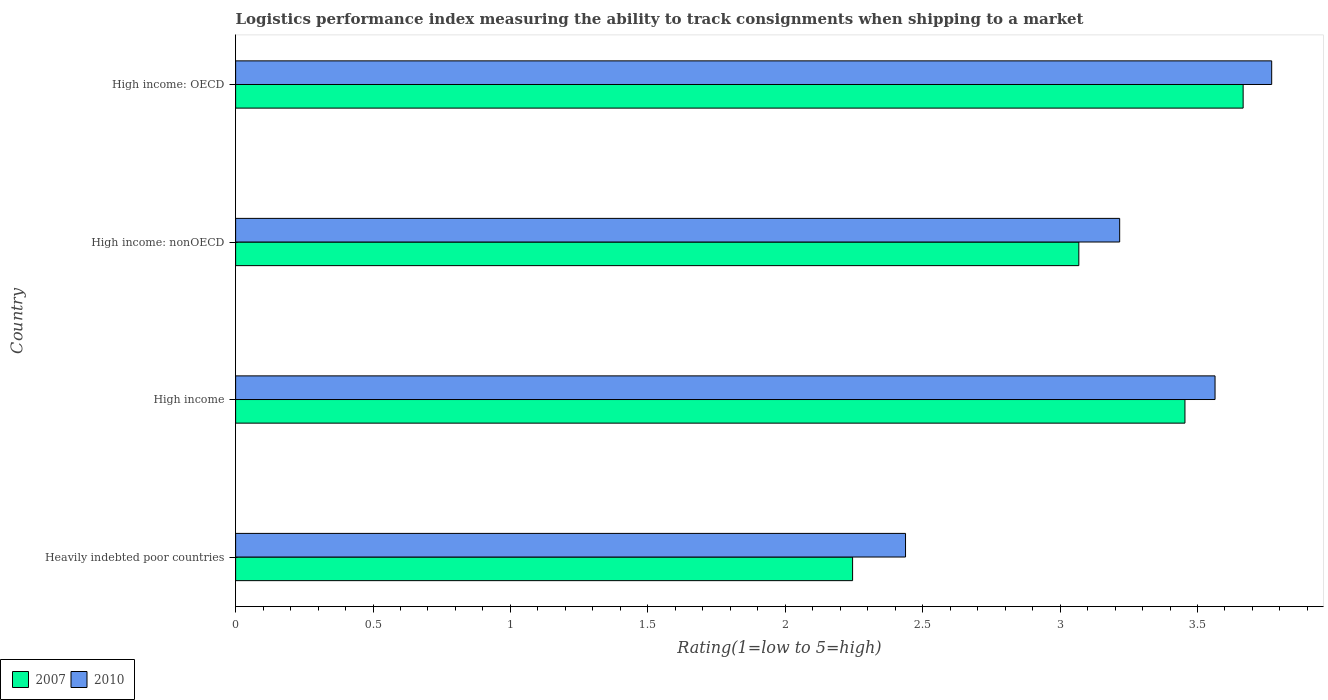Are the number of bars on each tick of the Y-axis equal?
Your response must be concise. Yes. How many bars are there on the 2nd tick from the bottom?
Make the answer very short. 2. What is the label of the 1st group of bars from the top?
Provide a short and direct response. High income: OECD. In how many cases, is the number of bars for a given country not equal to the number of legend labels?
Offer a very short reply. 0. What is the Logistic performance index in 2010 in High income: nonOECD?
Ensure brevity in your answer.  3.22. Across all countries, what is the maximum Logistic performance index in 2010?
Ensure brevity in your answer.  3.77. Across all countries, what is the minimum Logistic performance index in 2007?
Give a very brief answer. 2.25. In which country was the Logistic performance index in 2010 maximum?
Your response must be concise. High income: OECD. In which country was the Logistic performance index in 2010 minimum?
Offer a terse response. Heavily indebted poor countries. What is the total Logistic performance index in 2010 in the graph?
Ensure brevity in your answer.  12.99. What is the difference between the Logistic performance index in 2010 in Heavily indebted poor countries and that in High income: OECD?
Offer a terse response. -1.33. What is the difference between the Logistic performance index in 2007 in High income: nonOECD and the Logistic performance index in 2010 in High income?
Make the answer very short. -0.5. What is the average Logistic performance index in 2010 per country?
Provide a short and direct response. 3.25. What is the difference between the Logistic performance index in 2007 and Logistic performance index in 2010 in High income: nonOECD?
Your response must be concise. -0.15. What is the ratio of the Logistic performance index in 2007 in High income to that in High income: nonOECD?
Give a very brief answer. 1.13. Is the difference between the Logistic performance index in 2007 in High income and High income: nonOECD greater than the difference between the Logistic performance index in 2010 in High income and High income: nonOECD?
Ensure brevity in your answer.  Yes. What is the difference between the highest and the second highest Logistic performance index in 2007?
Your answer should be very brief. 0.21. What is the difference between the highest and the lowest Logistic performance index in 2010?
Your response must be concise. 1.33. Is the sum of the Logistic performance index in 2010 in High income and High income: OECD greater than the maximum Logistic performance index in 2007 across all countries?
Your response must be concise. Yes. What does the 1st bar from the bottom in High income: nonOECD represents?
Offer a very short reply. 2007. Are all the bars in the graph horizontal?
Ensure brevity in your answer.  Yes. What is the difference between two consecutive major ticks on the X-axis?
Your answer should be compact. 0.5. What is the title of the graph?
Ensure brevity in your answer.  Logistics performance index measuring the ability to track consignments when shipping to a market. What is the label or title of the X-axis?
Offer a terse response. Rating(1=low to 5=high). What is the label or title of the Y-axis?
Make the answer very short. Country. What is the Rating(1=low to 5=high) in 2007 in Heavily indebted poor countries?
Give a very brief answer. 2.25. What is the Rating(1=low to 5=high) of 2010 in Heavily indebted poor countries?
Your response must be concise. 2.44. What is the Rating(1=low to 5=high) of 2007 in High income?
Your answer should be compact. 3.45. What is the Rating(1=low to 5=high) in 2010 in High income?
Offer a terse response. 3.56. What is the Rating(1=low to 5=high) in 2007 in High income: nonOECD?
Your answer should be compact. 3.07. What is the Rating(1=low to 5=high) in 2010 in High income: nonOECD?
Provide a short and direct response. 3.22. What is the Rating(1=low to 5=high) of 2007 in High income: OECD?
Keep it short and to the point. 3.67. What is the Rating(1=low to 5=high) in 2010 in High income: OECD?
Make the answer very short. 3.77. Across all countries, what is the maximum Rating(1=low to 5=high) in 2007?
Your answer should be very brief. 3.67. Across all countries, what is the maximum Rating(1=low to 5=high) of 2010?
Provide a succinct answer. 3.77. Across all countries, what is the minimum Rating(1=low to 5=high) in 2007?
Ensure brevity in your answer.  2.25. Across all countries, what is the minimum Rating(1=low to 5=high) in 2010?
Offer a very short reply. 2.44. What is the total Rating(1=low to 5=high) of 2007 in the graph?
Provide a short and direct response. 12.43. What is the total Rating(1=low to 5=high) of 2010 in the graph?
Your response must be concise. 12.99. What is the difference between the Rating(1=low to 5=high) of 2007 in Heavily indebted poor countries and that in High income?
Provide a short and direct response. -1.21. What is the difference between the Rating(1=low to 5=high) of 2010 in Heavily indebted poor countries and that in High income?
Provide a short and direct response. -1.13. What is the difference between the Rating(1=low to 5=high) in 2007 in Heavily indebted poor countries and that in High income: nonOECD?
Provide a short and direct response. -0.82. What is the difference between the Rating(1=low to 5=high) of 2010 in Heavily indebted poor countries and that in High income: nonOECD?
Your response must be concise. -0.78. What is the difference between the Rating(1=low to 5=high) in 2007 in Heavily indebted poor countries and that in High income: OECD?
Your answer should be compact. -1.42. What is the difference between the Rating(1=low to 5=high) of 2010 in Heavily indebted poor countries and that in High income: OECD?
Give a very brief answer. -1.33. What is the difference between the Rating(1=low to 5=high) of 2007 in High income and that in High income: nonOECD?
Ensure brevity in your answer.  0.39. What is the difference between the Rating(1=low to 5=high) in 2010 in High income and that in High income: nonOECD?
Make the answer very short. 0.35. What is the difference between the Rating(1=low to 5=high) of 2007 in High income and that in High income: OECD?
Offer a terse response. -0.21. What is the difference between the Rating(1=low to 5=high) of 2010 in High income and that in High income: OECD?
Provide a succinct answer. -0.21. What is the difference between the Rating(1=low to 5=high) of 2007 in High income: nonOECD and that in High income: OECD?
Make the answer very short. -0.6. What is the difference between the Rating(1=low to 5=high) of 2010 in High income: nonOECD and that in High income: OECD?
Provide a short and direct response. -0.55. What is the difference between the Rating(1=low to 5=high) in 2007 in Heavily indebted poor countries and the Rating(1=low to 5=high) in 2010 in High income?
Make the answer very short. -1.32. What is the difference between the Rating(1=low to 5=high) of 2007 in Heavily indebted poor countries and the Rating(1=low to 5=high) of 2010 in High income: nonOECD?
Offer a very short reply. -0.97. What is the difference between the Rating(1=low to 5=high) of 2007 in Heavily indebted poor countries and the Rating(1=low to 5=high) of 2010 in High income: OECD?
Ensure brevity in your answer.  -1.52. What is the difference between the Rating(1=low to 5=high) in 2007 in High income and the Rating(1=low to 5=high) in 2010 in High income: nonOECD?
Keep it short and to the point. 0.24. What is the difference between the Rating(1=low to 5=high) in 2007 in High income and the Rating(1=low to 5=high) in 2010 in High income: OECD?
Keep it short and to the point. -0.32. What is the difference between the Rating(1=low to 5=high) in 2007 in High income: nonOECD and the Rating(1=low to 5=high) in 2010 in High income: OECD?
Provide a succinct answer. -0.7. What is the average Rating(1=low to 5=high) in 2007 per country?
Offer a very short reply. 3.11. What is the average Rating(1=low to 5=high) of 2010 per country?
Provide a short and direct response. 3.25. What is the difference between the Rating(1=low to 5=high) of 2007 and Rating(1=low to 5=high) of 2010 in Heavily indebted poor countries?
Make the answer very short. -0.19. What is the difference between the Rating(1=low to 5=high) in 2007 and Rating(1=low to 5=high) in 2010 in High income?
Provide a succinct answer. -0.11. What is the difference between the Rating(1=low to 5=high) of 2007 and Rating(1=low to 5=high) of 2010 in High income: nonOECD?
Provide a short and direct response. -0.15. What is the difference between the Rating(1=low to 5=high) in 2007 and Rating(1=low to 5=high) in 2010 in High income: OECD?
Give a very brief answer. -0.1. What is the ratio of the Rating(1=low to 5=high) in 2007 in Heavily indebted poor countries to that in High income?
Keep it short and to the point. 0.65. What is the ratio of the Rating(1=low to 5=high) of 2010 in Heavily indebted poor countries to that in High income?
Offer a very short reply. 0.68. What is the ratio of the Rating(1=low to 5=high) of 2007 in Heavily indebted poor countries to that in High income: nonOECD?
Your answer should be compact. 0.73. What is the ratio of the Rating(1=low to 5=high) in 2010 in Heavily indebted poor countries to that in High income: nonOECD?
Keep it short and to the point. 0.76. What is the ratio of the Rating(1=low to 5=high) of 2007 in Heavily indebted poor countries to that in High income: OECD?
Offer a terse response. 0.61. What is the ratio of the Rating(1=low to 5=high) of 2010 in Heavily indebted poor countries to that in High income: OECD?
Offer a terse response. 0.65. What is the ratio of the Rating(1=low to 5=high) of 2007 in High income to that in High income: nonOECD?
Provide a succinct answer. 1.13. What is the ratio of the Rating(1=low to 5=high) in 2010 in High income to that in High income: nonOECD?
Provide a short and direct response. 1.11. What is the ratio of the Rating(1=low to 5=high) of 2007 in High income to that in High income: OECD?
Provide a succinct answer. 0.94. What is the ratio of the Rating(1=low to 5=high) of 2010 in High income to that in High income: OECD?
Make the answer very short. 0.95. What is the ratio of the Rating(1=low to 5=high) of 2007 in High income: nonOECD to that in High income: OECD?
Give a very brief answer. 0.84. What is the ratio of the Rating(1=low to 5=high) in 2010 in High income: nonOECD to that in High income: OECD?
Make the answer very short. 0.85. What is the difference between the highest and the second highest Rating(1=low to 5=high) of 2007?
Offer a terse response. 0.21. What is the difference between the highest and the second highest Rating(1=low to 5=high) of 2010?
Give a very brief answer. 0.21. What is the difference between the highest and the lowest Rating(1=low to 5=high) in 2007?
Your answer should be very brief. 1.42. What is the difference between the highest and the lowest Rating(1=low to 5=high) in 2010?
Provide a succinct answer. 1.33. 